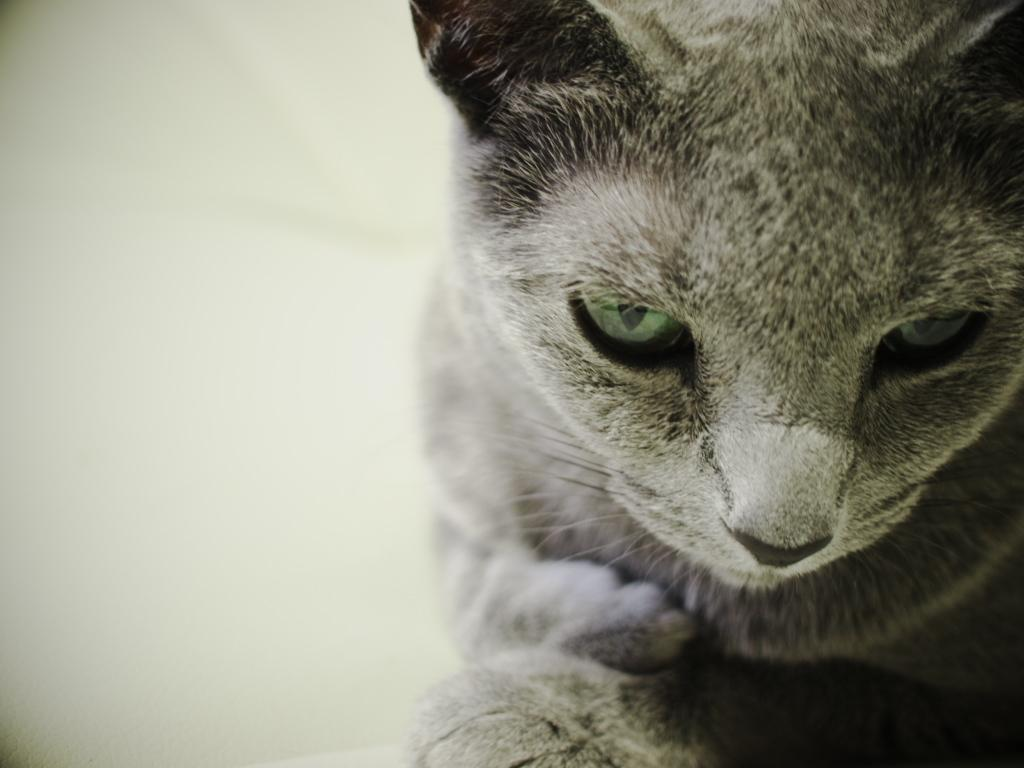What type of animal is present in the image? There is a cat in the image. Where is the cat located in the image? The cat is located towards the right side of the image. What color is the background of the image? The background of the image is white in color. What type of board game is the cat playing in the image? There is no board game present in the image; it features a cat in a white background. 